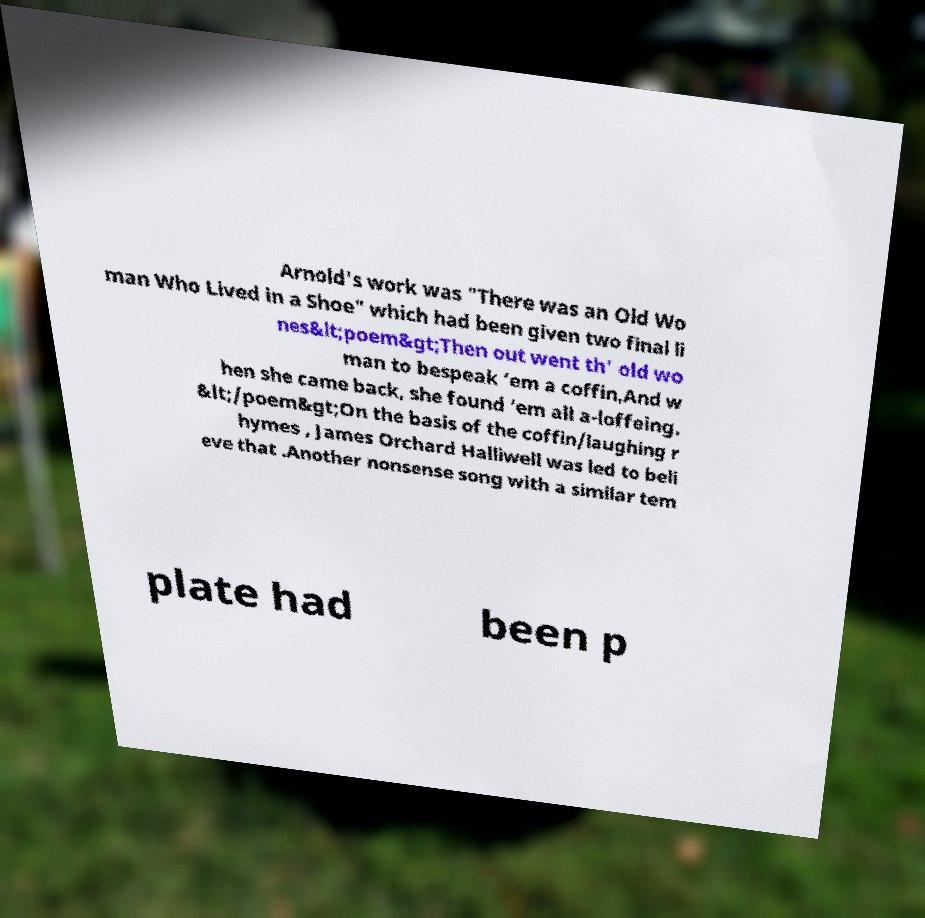Can you read and provide the text displayed in the image?This photo seems to have some interesting text. Can you extract and type it out for me? Arnold's work was "There was an Old Wo man Who Lived in a Shoe" which had been given two final li nes&lt;poem&gt;Then out went th' old wo man to bespeak ‘em a coffin,And w hen she came back, she found ‘em all a-loffeing. &lt;/poem&gt;On the basis of the coffin/laughing r hymes , James Orchard Halliwell was led to beli eve that .Another nonsense song with a similar tem plate had been p 